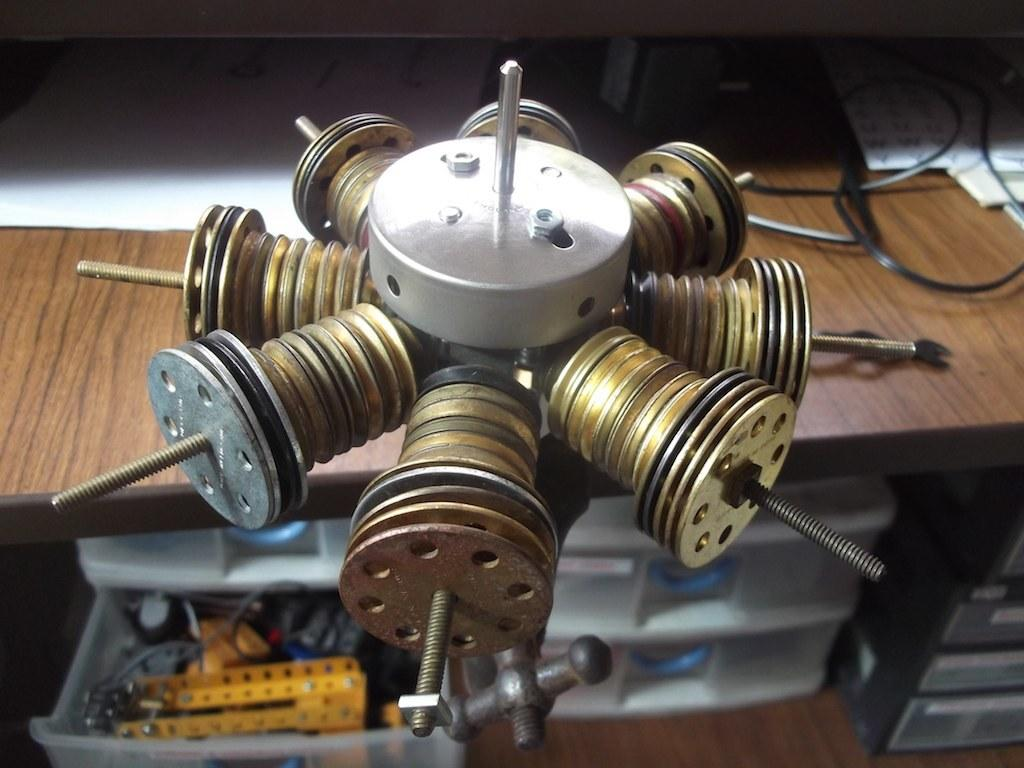What is the main object in the image? There is a device in the image. What else can be seen on the table with the device? Papers, cables, and boxes are visible in the image. What might be used to connect the device to a power source or other devices? Cables are visible in the image, which could be used for connecting the device. Where are the objects in the image located? The objects are on a table. How does the donkey react to the earthquake in the image? There is no donkey or earthquake present in the image. 